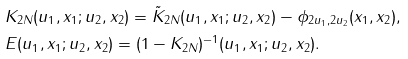<formula> <loc_0><loc_0><loc_500><loc_500>& K _ { 2 N } ( u _ { 1 } , x _ { 1 } ; u _ { 2 } , x _ { 2 } ) = \tilde { K } _ { 2 N } ( u _ { 1 } , x _ { 1 } ; u _ { 2 } , x _ { 2 } ) - \phi _ { 2 u _ { 1 } , 2 u _ { 2 } } ( x _ { 1 } , x _ { 2 } ) , \\ & E ( u _ { 1 } , x _ { 1 } ; u _ { 2 } , x _ { 2 } ) = ( 1 - K _ { 2 N } ) ^ { - 1 } ( u _ { 1 } , x _ { 1 } ; u _ { 2 } , x _ { 2 } ) .</formula> 